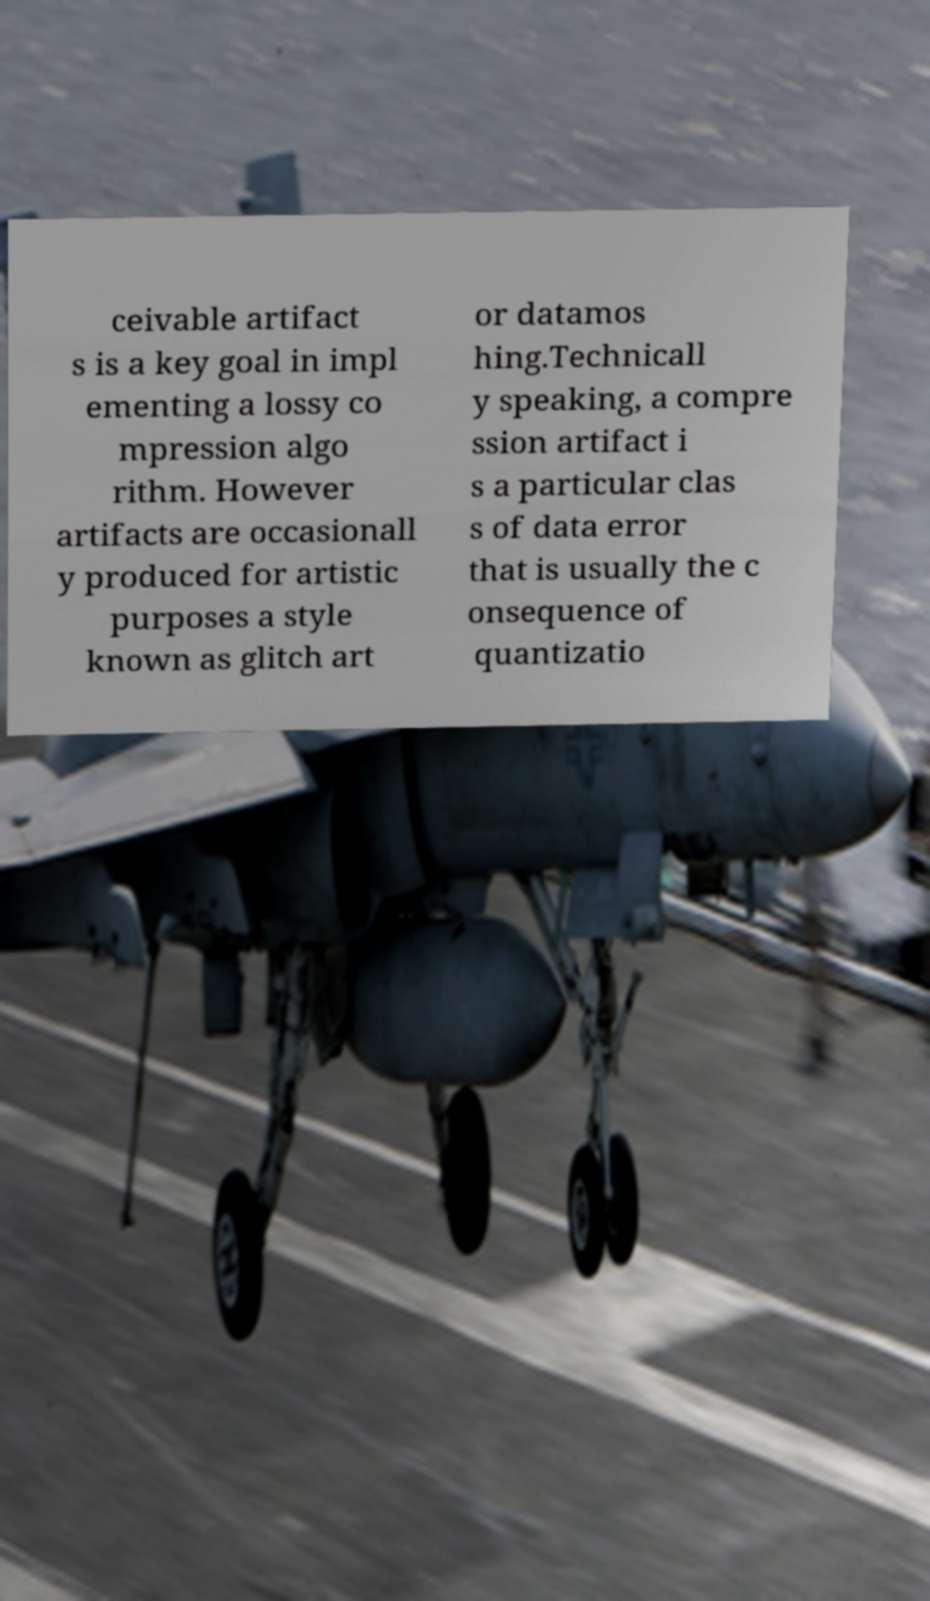Can you read and provide the text displayed in the image?This photo seems to have some interesting text. Can you extract and type it out for me? ceivable artifact s is a key goal in impl ementing a lossy co mpression algo rithm. However artifacts are occasionall y produced for artistic purposes a style known as glitch art or datamos hing.Technicall y speaking, a compre ssion artifact i s a particular clas s of data error that is usually the c onsequence of quantizatio 